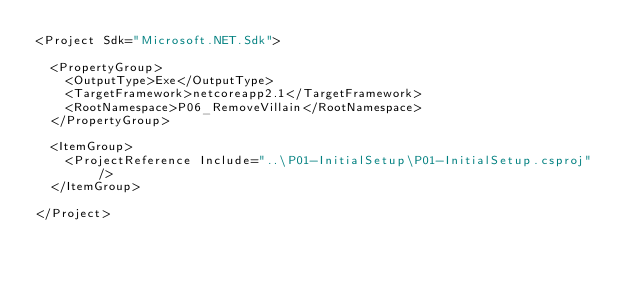<code> <loc_0><loc_0><loc_500><loc_500><_XML_><Project Sdk="Microsoft.NET.Sdk">

  <PropertyGroup>
    <OutputType>Exe</OutputType>
    <TargetFramework>netcoreapp2.1</TargetFramework>
    <RootNamespace>P06_RemoveVillain</RootNamespace>
  </PropertyGroup>

  <ItemGroup>
    <ProjectReference Include="..\P01-InitialSetup\P01-InitialSetup.csproj" />
  </ItemGroup>

</Project>
</code> 